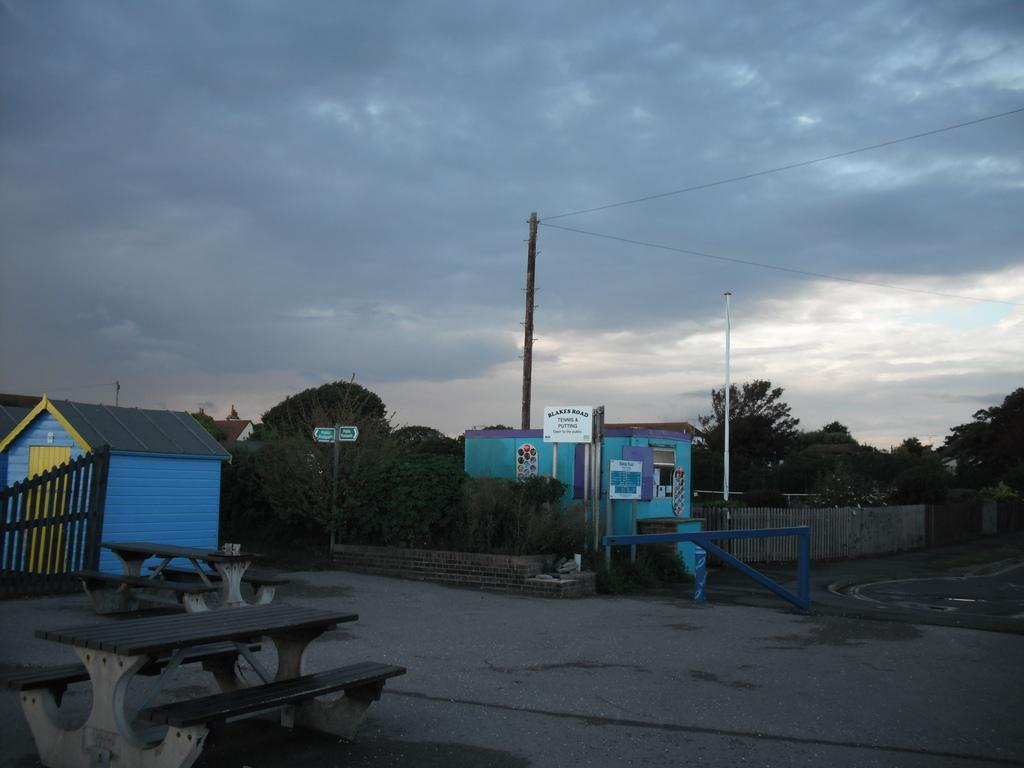What type of outdoor seating is present in the image? There are benches on the ground in the image. What type of barrier is present in the image? There is fencing in the image. What type of structures can be seen in the image? There are houses in the image. What type of vegetation is present in the image? There are trees in the image. What type of vertical structure is present in the image? There is a pole in the image. What is attached to the pole in the image? There are two boards attached to the pole in the image. What is visible in the background of the image? The sky and trees are visible in the background of the image. What type of hobbies are being practiced by the trees in the image? Trees do not have hobbies, as they are inanimate objects. What type of weather can be seen in the image? The provided facts do not mention any specific weather conditions, so we cannot determine the weather from the image. 